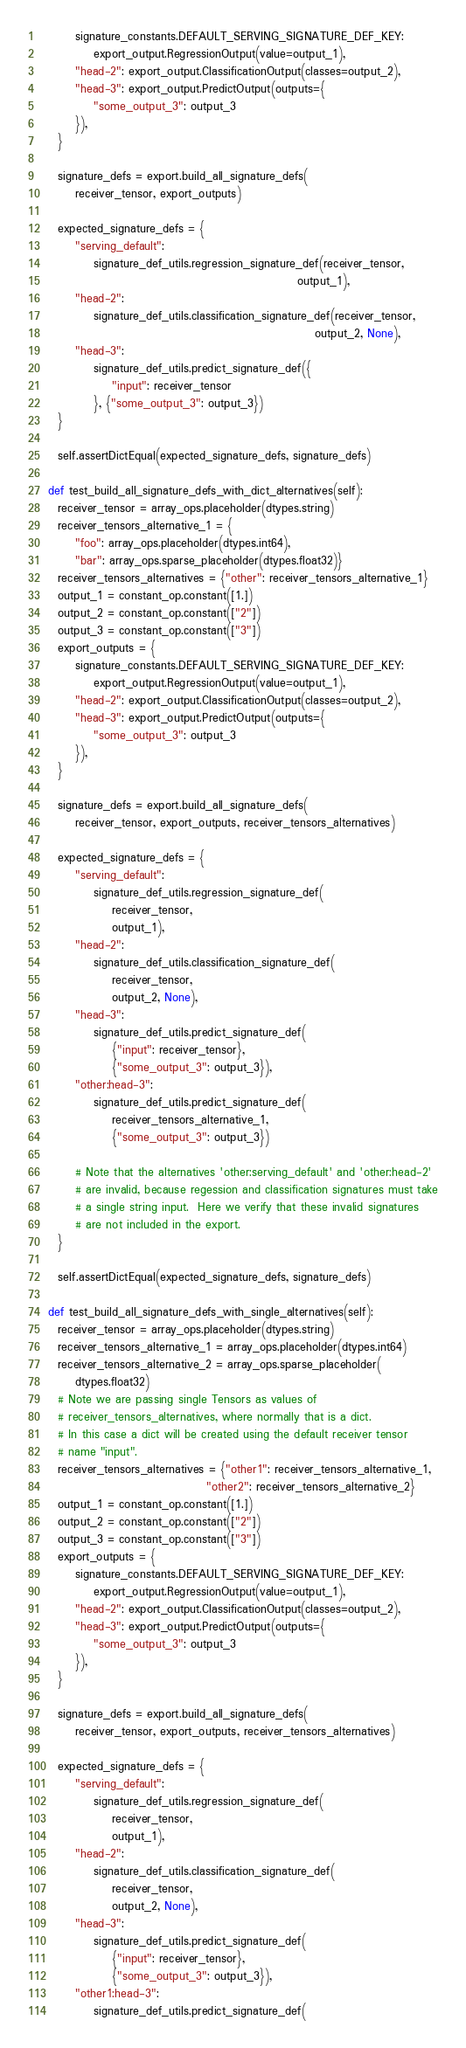Convert code to text. <code><loc_0><loc_0><loc_500><loc_500><_Python_>        signature_constants.DEFAULT_SERVING_SIGNATURE_DEF_KEY:
            export_output.RegressionOutput(value=output_1),
        "head-2": export_output.ClassificationOutput(classes=output_2),
        "head-3": export_output.PredictOutput(outputs={
            "some_output_3": output_3
        }),
    }

    signature_defs = export.build_all_signature_defs(
        receiver_tensor, export_outputs)

    expected_signature_defs = {
        "serving_default":
            signature_def_utils.regression_signature_def(receiver_tensor,
                                                         output_1),
        "head-2":
            signature_def_utils.classification_signature_def(receiver_tensor,
                                                             output_2, None),
        "head-3":
            signature_def_utils.predict_signature_def({
                "input": receiver_tensor
            }, {"some_output_3": output_3})
    }

    self.assertDictEqual(expected_signature_defs, signature_defs)

  def test_build_all_signature_defs_with_dict_alternatives(self):
    receiver_tensor = array_ops.placeholder(dtypes.string)
    receiver_tensors_alternative_1 = {
        "foo": array_ops.placeholder(dtypes.int64),
        "bar": array_ops.sparse_placeholder(dtypes.float32)}
    receiver_tensors_alternatives = {"other": receiver_tensors_alternative_1}
    output_1 = constant_op.constant([1.])
    output_2 = constant_op.constant(["2"])
    output_3 = constant_op.constant(["3"])
    export_outputs = {
        signature_constants.DEFAULT_SERVING_SIGNATURE_DEF_KEY:
            export_output.RegressionOutput(value=output_1),
        "head-2": export_output.ClassificationOutput(classes=output_2),
        "head-3": export_output.PredictOutput(outputs={
            "some_output_3": output_3
        }),
    }

    signature_defs = export.build_all_signature_defs(
        receiver_tensor, export_outputs, receiver_tensors_alternatives)

    expected_signature_defs = {
        "serving_default":
            signature_def_utils.regression_signature_def(
                receiver_tensor,
                output_1),
        "head-2":
            signature_def_utils.classification_signature_def(
                receiver_tensor,
                output_2, None),
        "head-3":
            signature_def_utils.predict_signature_def(
                {"input": receiver_tensor},
                {"some_output_3": output_3}),
        "other:head-3":
            signature_def_utils.predict_signature_def(
                receiver_tensors_alternative_1,
                {"some_output_3": output_3})

        # Note that the alternatives 'other:serving_default' and 'other:head-2'
        # are invalid, because regession and classification signatures must take
        # a single string input.  Here we verify that these invalid signatures
        # are not included in the export.
    }

    self.assertDictEqual(expected_signature_defs, signature_defs)

  def test_build_all_signature_defs_with_single_alternatives(self):
    receiver_tensor = array_ops.placeholder(dtypes.string)
    receiver_tensors_alternative_1 = array_ops.placeholder(dtypes.int64)
    receiver_tensors_alternative_2 = array_ops.sparse_placeholder(
        dtypes.float32)
    # Note we are passing single Tensors as values of
    # receiver_tensors_alternatives, where normally that is a dict.
    # In this case a dict will be created using the default receiver tensor
    # name "input".
    receiver_tensors_alternatives = {"other1": receiver_tensors_alternative_1,
                                     "other2": receiver_tensors_alternative_2}
    output_1 = constant_op.constant([1.])
    output_2 = constant_op.constant(["2"])
    output_3 = constant_op.constant(["3"])
    export_outputs = {
        signature_constants.DEFAULT_SERVING_SIGNATURE_DEF_KEY:
            export_output.RegressionOutput(value=output_1),
        "head-2": export_output.ClassificationOutput(classes=output_2),
        "head-3": export_output.PredictOutput(outputs={
            "some_output_3": output_3
        }),
    }

    signature_defs = export.build_all_signature_defs(
        receiver_tensor, export_outputs, receiver_tensors_alternatives)

    expected_signature_defs = {
        "serving_default":
            signature_def_utils.regression_signature_def(
                receiver_tensor,
                output_1),
        "head-2":
            signature_def_utils.classification_signature_def(
                receiver_tensor,
                output_2, None),
        "head-3":
            signature_def_utils.predict_signature_def(
                {"input": receiver_tensor},
                {"some_output_3": output_3}),
        "other1:head-3":
            signature_def_utils.predict_signature_def(</code> 